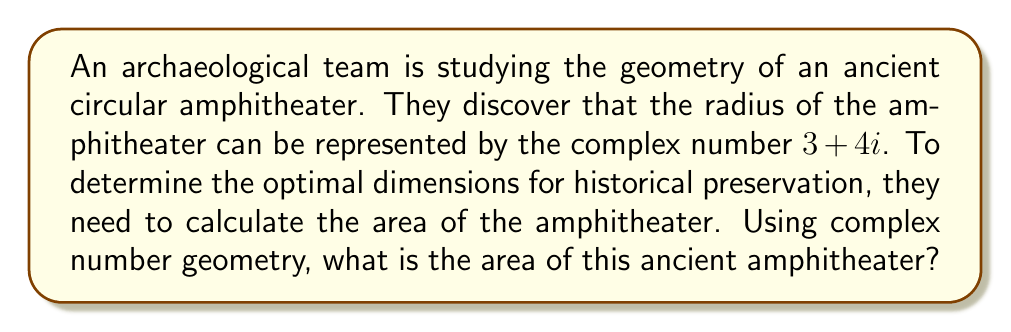Could you help me with this problem? Let's approach this step-by-step:

1) The radius of the amphitheater is given as $r = 3 + 4i$.

2) To find the area of a circle, we use the formula $A = \pi r^2$.

3) However, since $r$ is a complex number, we need to multiply it by its complex conjugate to get the squared magnitude:

   $r^2 = (3 + 4i)(3 - 4i) = 3^2 + 4^2 = 9 + 16 = 25$

4) Now we can apply the area formula:

   $A = \pi r^2 = \pi \cdot 25 = 25\pi$

5) Therefore, the area of the amphitheater is $25\pi$ square units.

This method demonstrates how complex numbers can be used to solve geometric problems in historical contexts, providing a precise measurement for preservation efforts.
Answer: $25\pi$ square units 